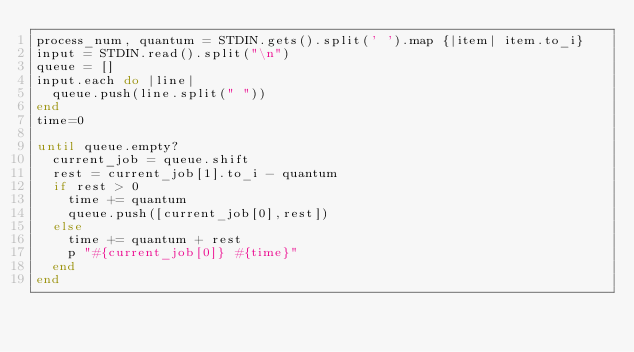<code> <loc_0><loc_0><loc_500><loc_500><_Ruby_>process_num, quantum = STDIN.gets().split(' ').map {|item| item.to_i}
input = STDIN.read().split("\n")
queue = []
input.each do |line|
  queue.push(line.split(" "))
end
time=0

until queue.empty?
  current_job = queue.shift
  rest = current_job[1].to_i - quantum
  if rest > 0
    time += quantum
    queue.push([current_job[0],rest])
  else
    time += quantum + rest
    p "#{current_job[0]} #{time}"
  end
end</code> 